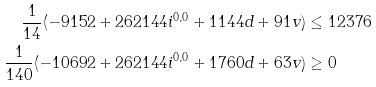Convert formula to latex. <formula><loc_0><loc_0><loc_500><loc_500>\frac { 1 } { 1 4 } ( - 9 1 5 2 + 2 6 2 1 4 4 i ^ { 0 , 0 } + 1 1 4 4 d + 9 1 v ) & \leq 1 2 3 7 6 \\ \frac { 1 } { 1 4 0 } ( - 1 0 6 9 2 + 2 6 2 1 4 4 i ^ { 0 , 0 } + 1 7 6 0 d + 6 3 v ) & \geq 0</formula> 